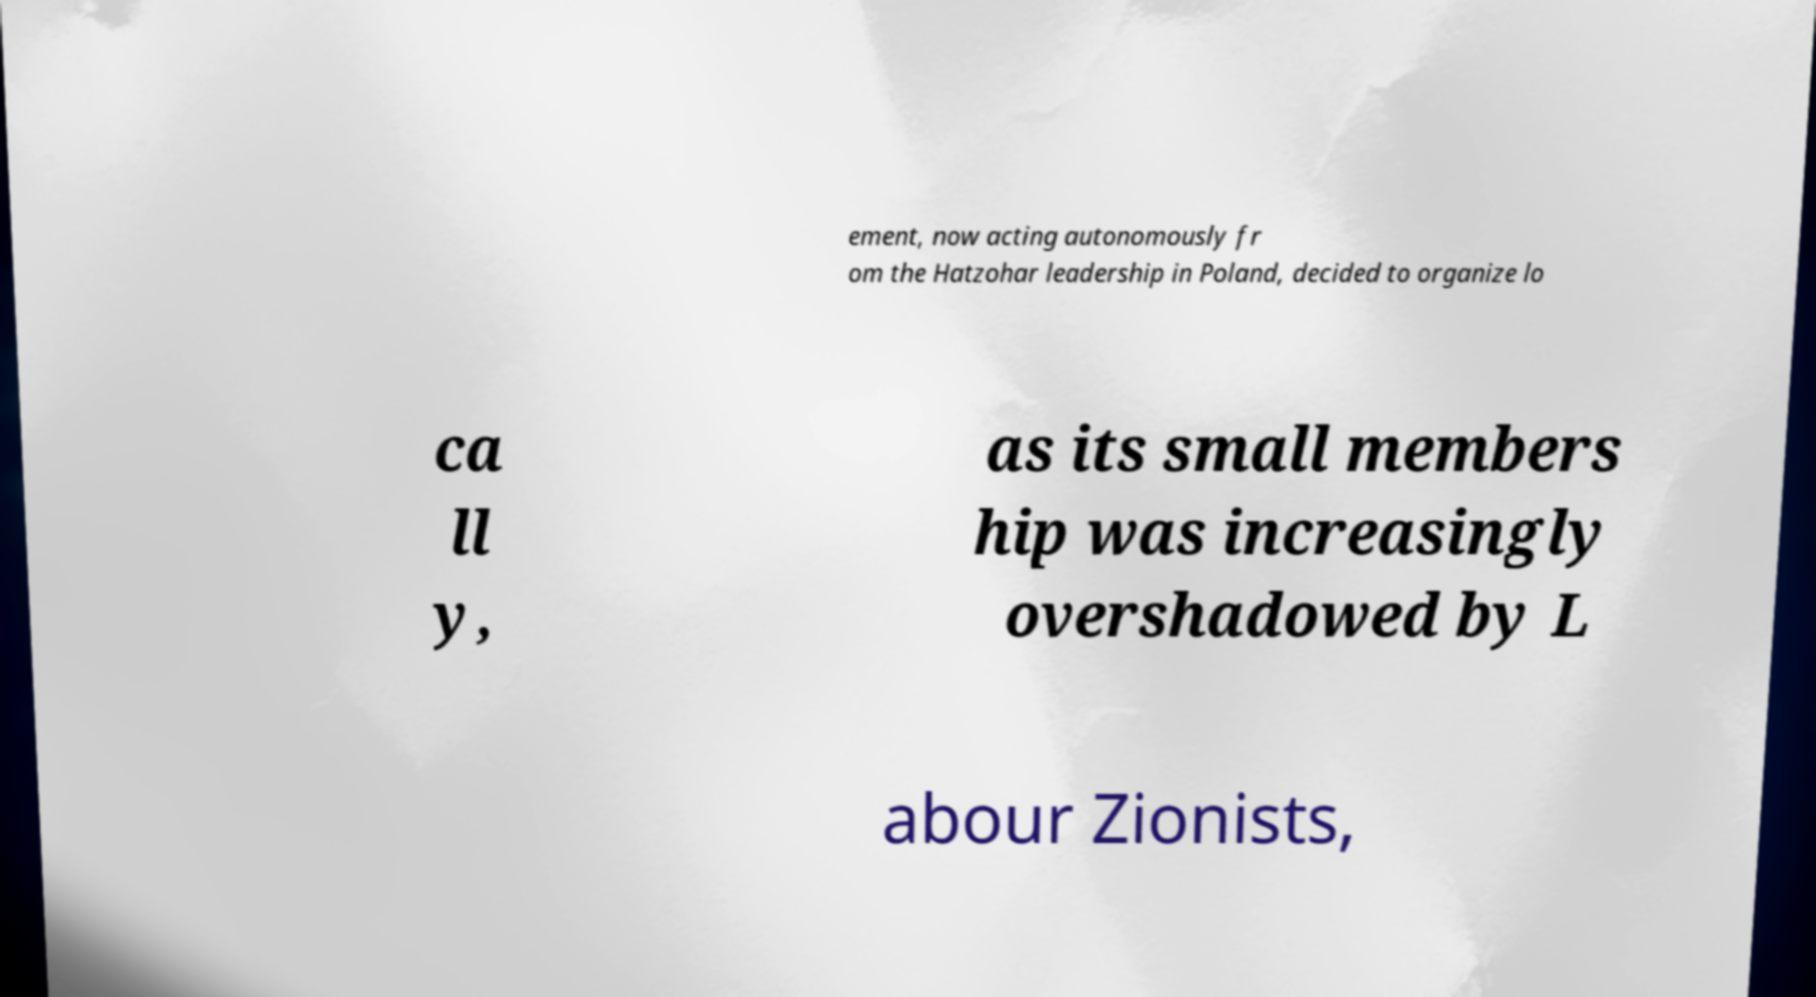Can you read and provide the text displayed in the image?This photo seems to have some interesting text. Can you extract and type it out for me? ement, now acting autonomously fr om the Hatzohar leadership in Poland, decided to organize lo ca ll y, as its small members hip was increasingly overshadowed by L abour Zionists, 